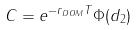Convert formula to latex. <formula><loc_0><loc_0><loc_500><loc_500>C = e ^ { - r _ { D O M } T } \Phi ( d _ { 2 } )</formula> 